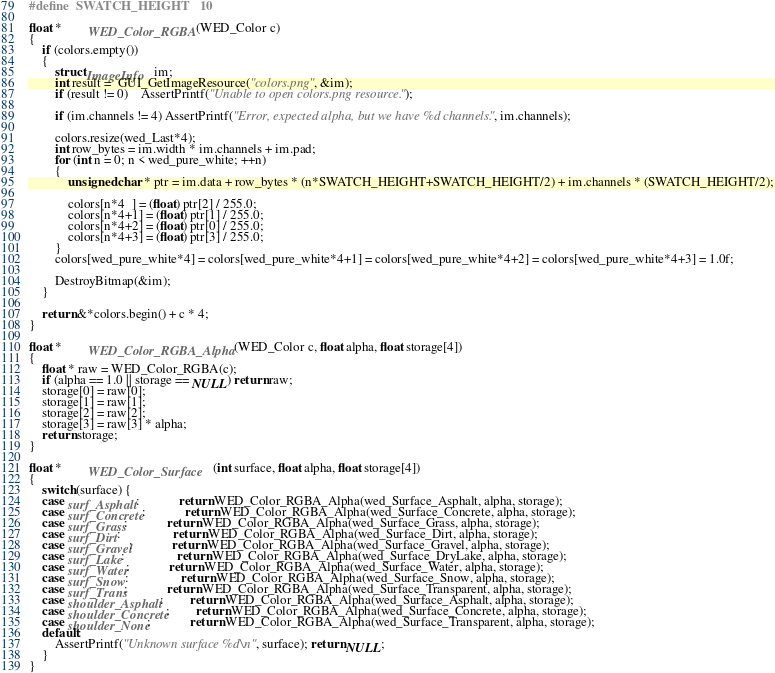<code> <loc_0><loc_0><loc_500><loc_500><_C++_>#define	SWATCH_HEIGHT	10

float *		WED_Color_RGBA(WED_Color c)
{
	if (colors.empty())
	{
		struct ImageInfo	im;
		int result =  GUI_GetImageResource("colors.png", &im);
		if (result != 0)	AssertPrintf("Unable to open colors.png resource.");

		if (im.channels != 4) AssertPrintf("Error, expected alpha, but we have %d channels.", im.channels);

		colors.resize(wed_Last*4);
		int row_bytes = im.width * im.channels + im.pad;
		for (int n = 0; n < wed_pure_white; ++n)
		{
			unsigned char * ptr = im.data + row_bytes * (n*SWATCH_HEIGHT+SWATCH_HEIGHT/2) + im.channels * (SWATCH_HEIGHT/2);

			colors[n*4  ] = (float) ptr[2] / 255.0;
			colors[n*4+1] = (float) ptr[1] / 255.0;
			colors[n*4+2] = (float) ptr[0] / 255.0;
			colors[n*4+3] = (float) ptr[3] / 255.0;
		}
		colors[wed_pure_white*4] = colors[wed_pure_white*4+1] = colors[wed_pure_white*4+2] = colors[wed_pure_white*4+3] = 1.0f;
		
		DestroyBitmap(&im);
	}

	return &*colors.begin() + c * 4;
}

float *		WED_Color_RGBA_Alpha(WED_Color c, float alpha, float storage[4])
{
	float * raw = WED_Color_RGBA(c);
	if (alpha == 1.0 || storage == NULL) return raw;
	storage[0] = raw[0];
	storage[1] = raw[1];
	storage[2] = raw[2];
	storage[3] = raw[3] * alpha;
	return storage;
}

float *		WED_Color_Surface	(int surface, float alpha, float storage[4])
{
	switch(surface) {
	case surf_Asphalt:			return WED_Color_RGBA_Alpha(wed_Surface_Asphalt, alpha, storage);
	case surf_Concrete:			return WED_Color_RGBA_Alpha(wed_Surface_Concrete, alpha, storage);
	case surf_Grass:			return WED_Color_RGBA_Alpha(wed_Surface_Grass, alpha, storage);
	case surf_Dirt:				return WED_Color_RGBA_Alpha(wed_Surface_Dirt, alpha, storage);
	case surf_Gravel:			return WED_Color_RGBA_Alpha(wed_Surface_Gravel, alpha, storage);
	case surf_Lake:				return WED_Color_RGBA_Alpha(wed_Surface_DryLake, alpha, storage);
	case surf_Water:			return WED_Color_RGBA_Alpha(wed_Surface_Water, alpha, storage);
	case surf_Snow:				return WED_Color_RGBA_Alpha(wed_Surface_Snow, alpha, storage);
	case surf_Trans:			return WED_Color_RGBA_Alpha(wed_Surface_Transparent, alpha, storage);
	case shoulder_Asphalt:		return WED_Color_RGBA_Alpha(wed_Surface_Asphalt, alpha, storage);
	case shoulder_Concrete:		return WED_Color_RGBA_Alpha(wed_Surface_Concrete, alpha, storage);
	case shoulder_None:			return WED_Color_RGBA_Alpha(wed_Surface_Transparent, alpha, storage);
	default:
		AssertPrintf("Unknown surface %d\n", surface); return NULL;
	}
}
</code> 